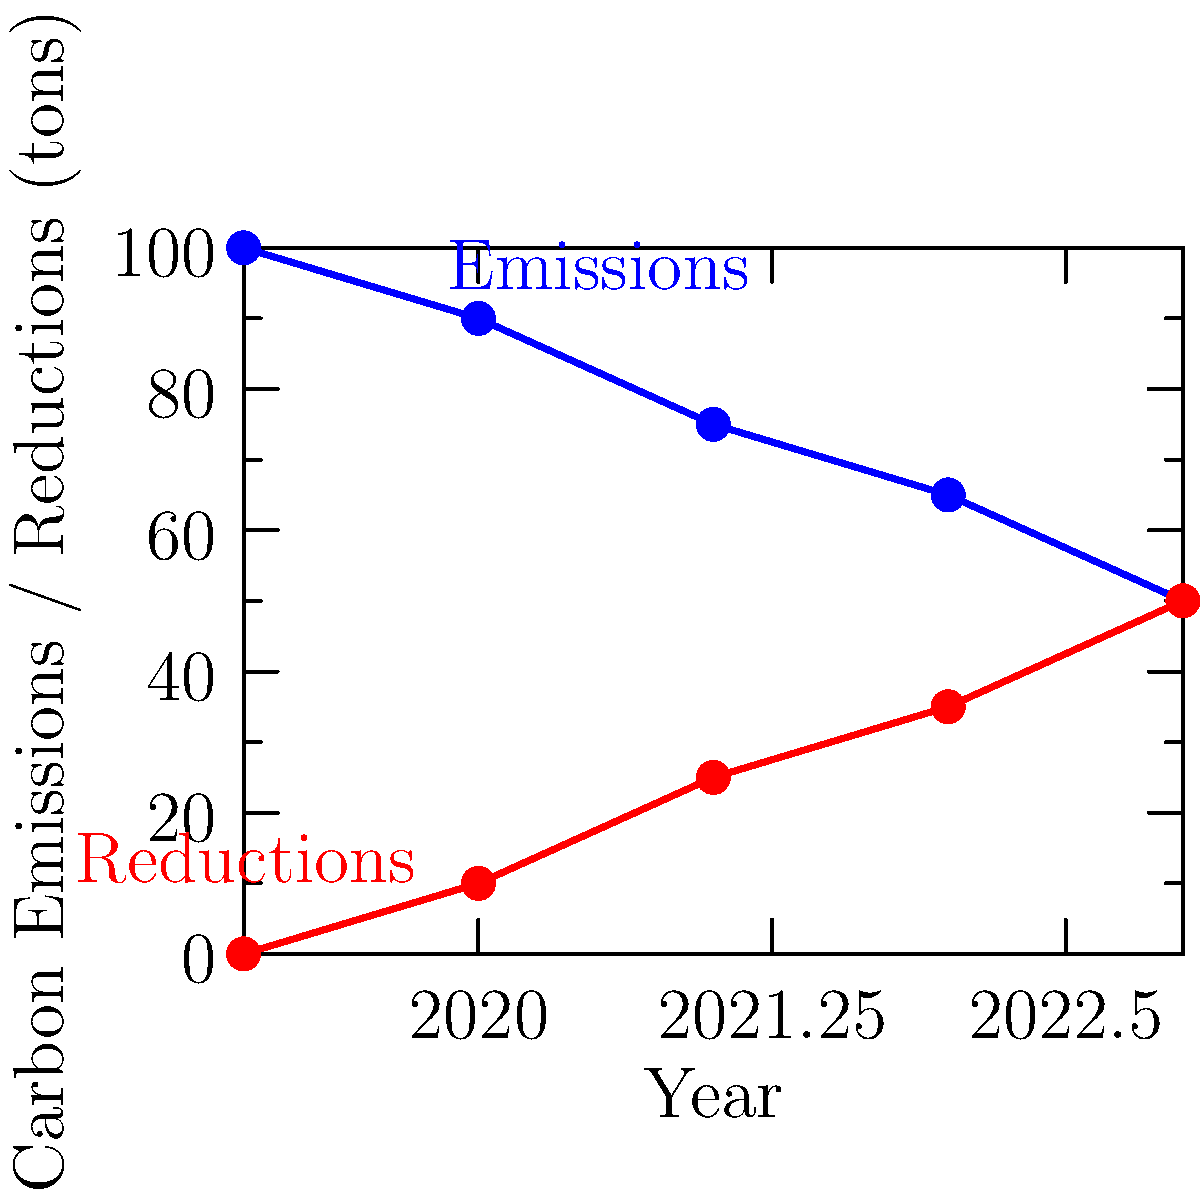As a philanthropist supporting conservation efforts through film, you're analyzing the impact of a recent documentary on carbon emissions. The graph shows the annual carbon emissions and reductions (in tons) for a community featured in your film. What was the total reduction in carbon emissions from 2019 to 2023? To calculate the total reduction in carbon emissions from 2019 to 2023, we need to follow these steps:

1. Identify the carbon emissions in 2019 and 2023:
   - 2019 emissions: 100 tons
   - 2023 emissions: 50 tons

2. Calculate the difference between these two values:
   $100 \text{ tons} - 50 \text{ tons} = 50 \text{ tons}$

3. Verify the result using the "Reductions" line on the graph:
   - The red line shows cumulative reductions over time
   - In 2023, the reduction value is 50 tons, which matches our calculation

Therefore, the total reduction in carbon emissions from 2019 to 2023 is 50 tons.

This significant reduction demonstrates the positive impact of conservation efforts inspired by the documentary, showcasing the power of film in promoting environmental awareness and action.
Answer: 50 tons 